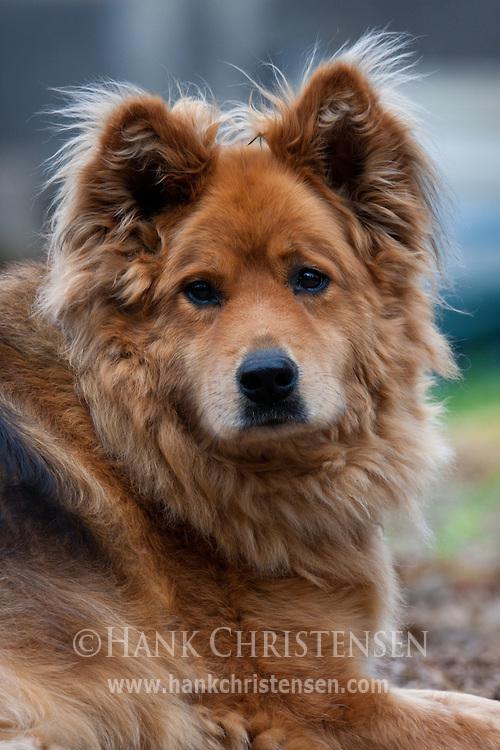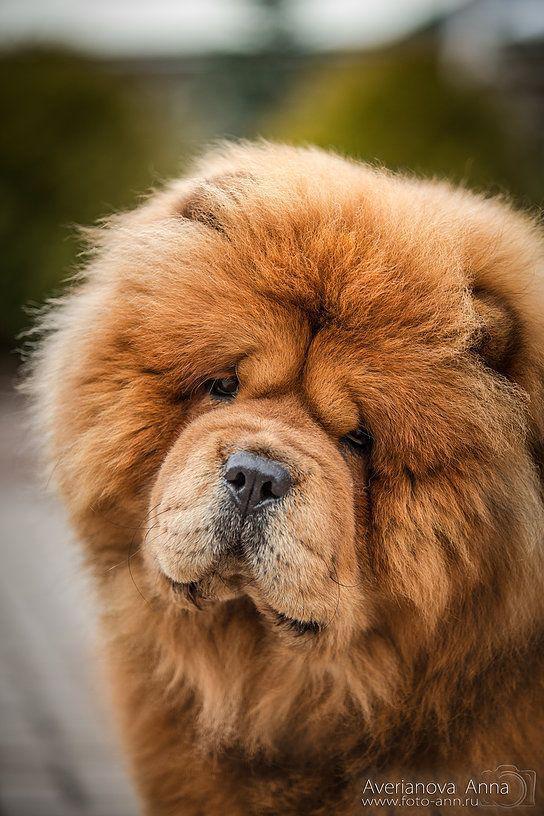The first image is the image on the left, the second image is the image on the right. Analyze the images presented: Is the assertion "Right image shows a chow dog standing with its body turned leftward." valid? Answer yes or no. No. The first image is the image on the left, the second image is the image on the right. Evaluate the accuracy of this statement regarding the images: "At least one of the furry dogs is standing in the grass.". Is it true? Answer yes or no. No. 